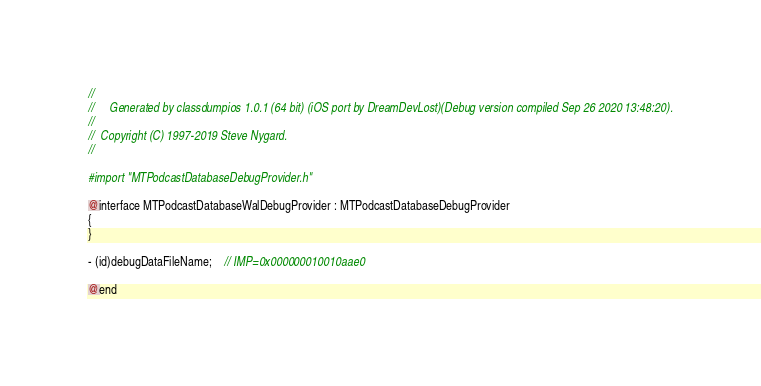Convert code to text. <code><loc_0><loc_0><loc_500><loc_500><_C_>//
//     Generated by classdumpios 1.0.1 (64 bit) (iOS port by DreamDevLost)(Debug version compiled Sep 26 2020 13:48:20).
//
//  Copyright (C) 1997-2019 Steve Nygard.
//

#import "MTPodcastDatabaseDebugProvider.h"

@interface MTPodcastDatabaseWalDebugProvider : MTPodcastDatabaseDebugProvider
{
}

- (id)debugDataFileName;	// IMP=0x000000010010aae0

@end

</code> 